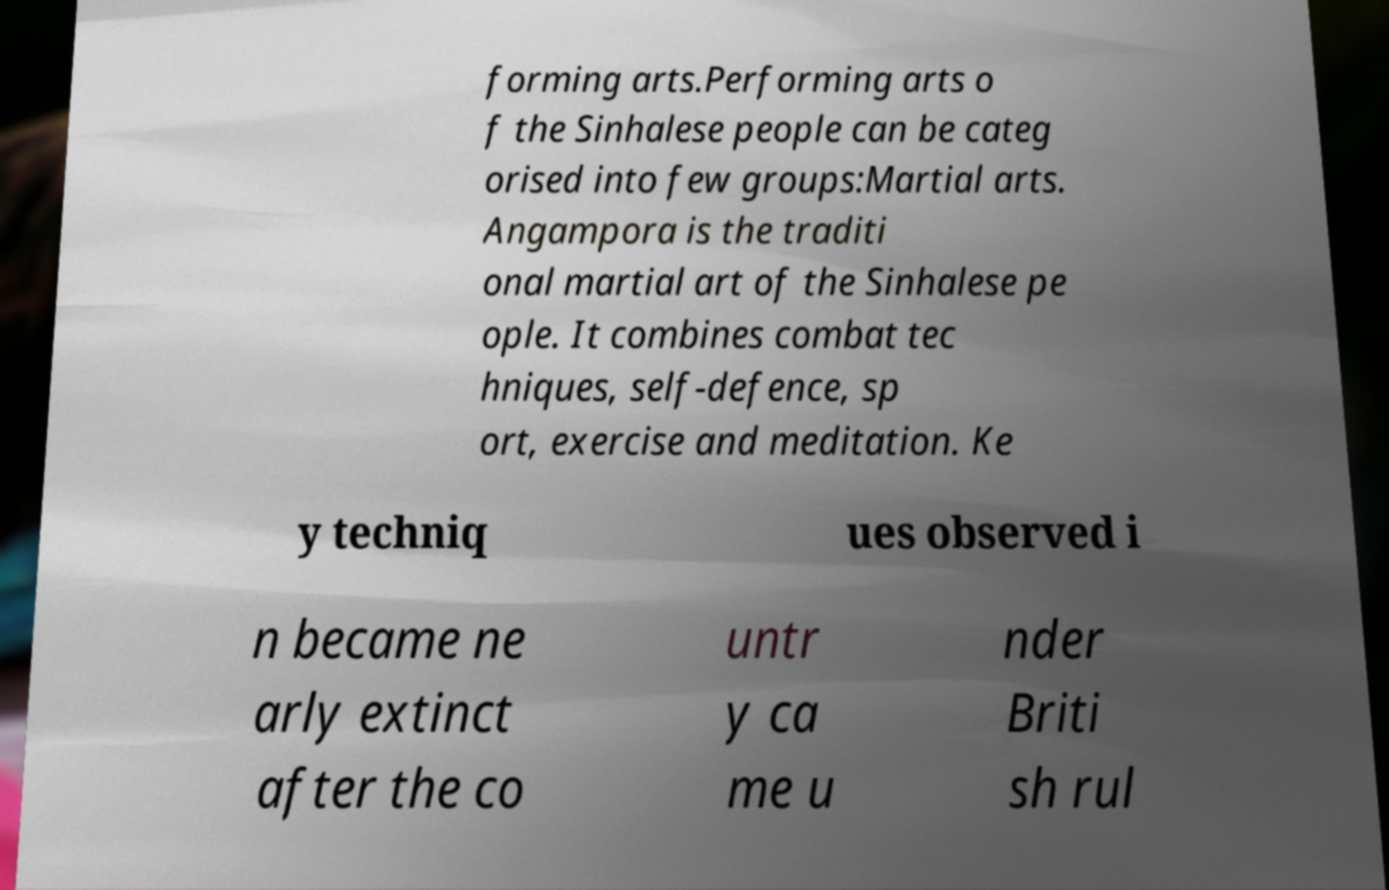What messages or text are displayed in this image? I need them in a readable, typed format. forming arts.Performing arts o f the Sinhalese people can be categ orised into few groups:Martial arts. Angampora is the traditi onal martial art of the Sinhalese pe ople. It combines combat tec hniques, self-defence, sp ort, exercise and meditation. Ke y techniq ues observed i n became ne arly extinct after the co untr y ca me u nder Briti sh rul 